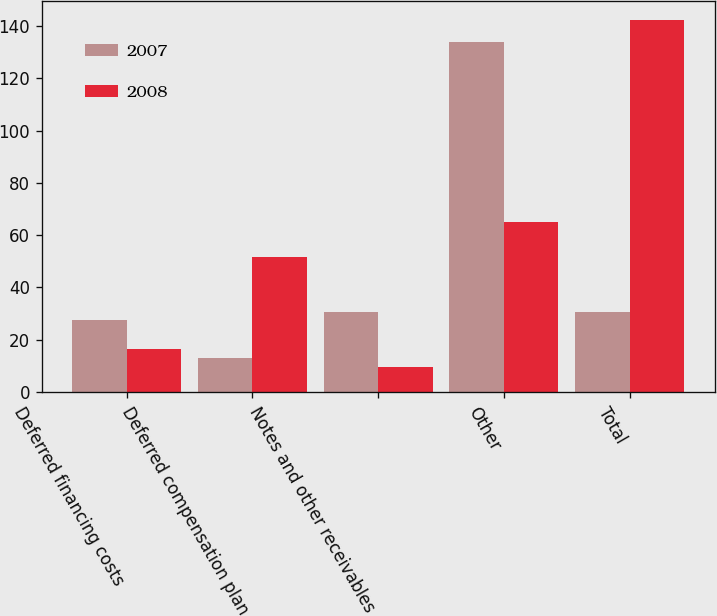<chart> <loc_0><loc_0><loc_500><loc_500><stacked_bar_chart><ecel><fcel>Deferred financing costs<fcel>Deferred compensation plan<fcel>Notes and other receivables<fcel>Other<fcel>Total<nl><fcel>2007<fcel>27.4<fcel>13<fcel>30.7<fcel>133.8<fcel>30.7<nl><fcel>2008<fcel>16.3<fcel>51.5<fcel>9.5<fcel>65.2<fcel>142.5<nl></chart> 